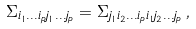Convert formula to latex. <formula><loc_0><loc_0><loc_500><loc_500>\Sigma _ { i _ { 1 } \dots i _ { p } j _ { 1 } \dots j _ { p } } = \Sigma _ { j _ { 1 } i _ { 2 } \dots i _ { p } i _ { 1 } j _ { 2 } \dots j _ { p } } \, ,</formula> 